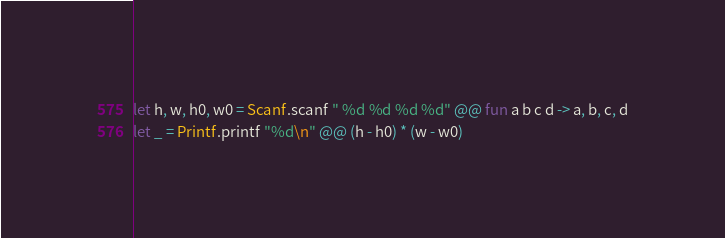<code> <loc_0><loc_0><loc_500><loc_500><_OCaml_>let h, w, h0, w0 = Scanf.scanf " %d %d %d %d" @@ fun a b c d -> a, b, c, d
let _ = Printf.printf "%d\n" @@ (h - h0) * (w - w0)</code> 